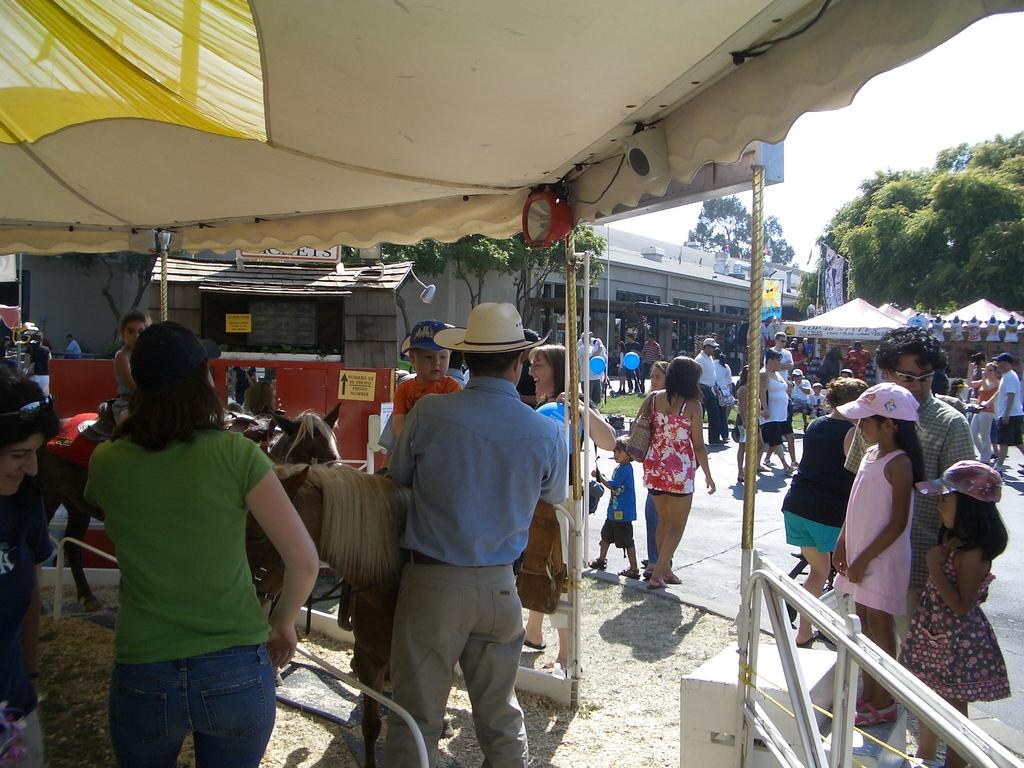Who or what can be seen in the image? There are people in the image. What type of structures are present in the image? There are stalls in the image. What natural elements are visible in the image? There are trees in the image. Can you describe any text or writing in the image? There is something written in the image. What type of surface is visible in the image? There is ground visible in the image. Are there any animals present in the image? Yes, there are horses in the image. How many boys are holding onto the wrist of the horse in the image? There is no mention of boys or wrists in the image; it features people, stalls, trees, writing, ground, and horses. 